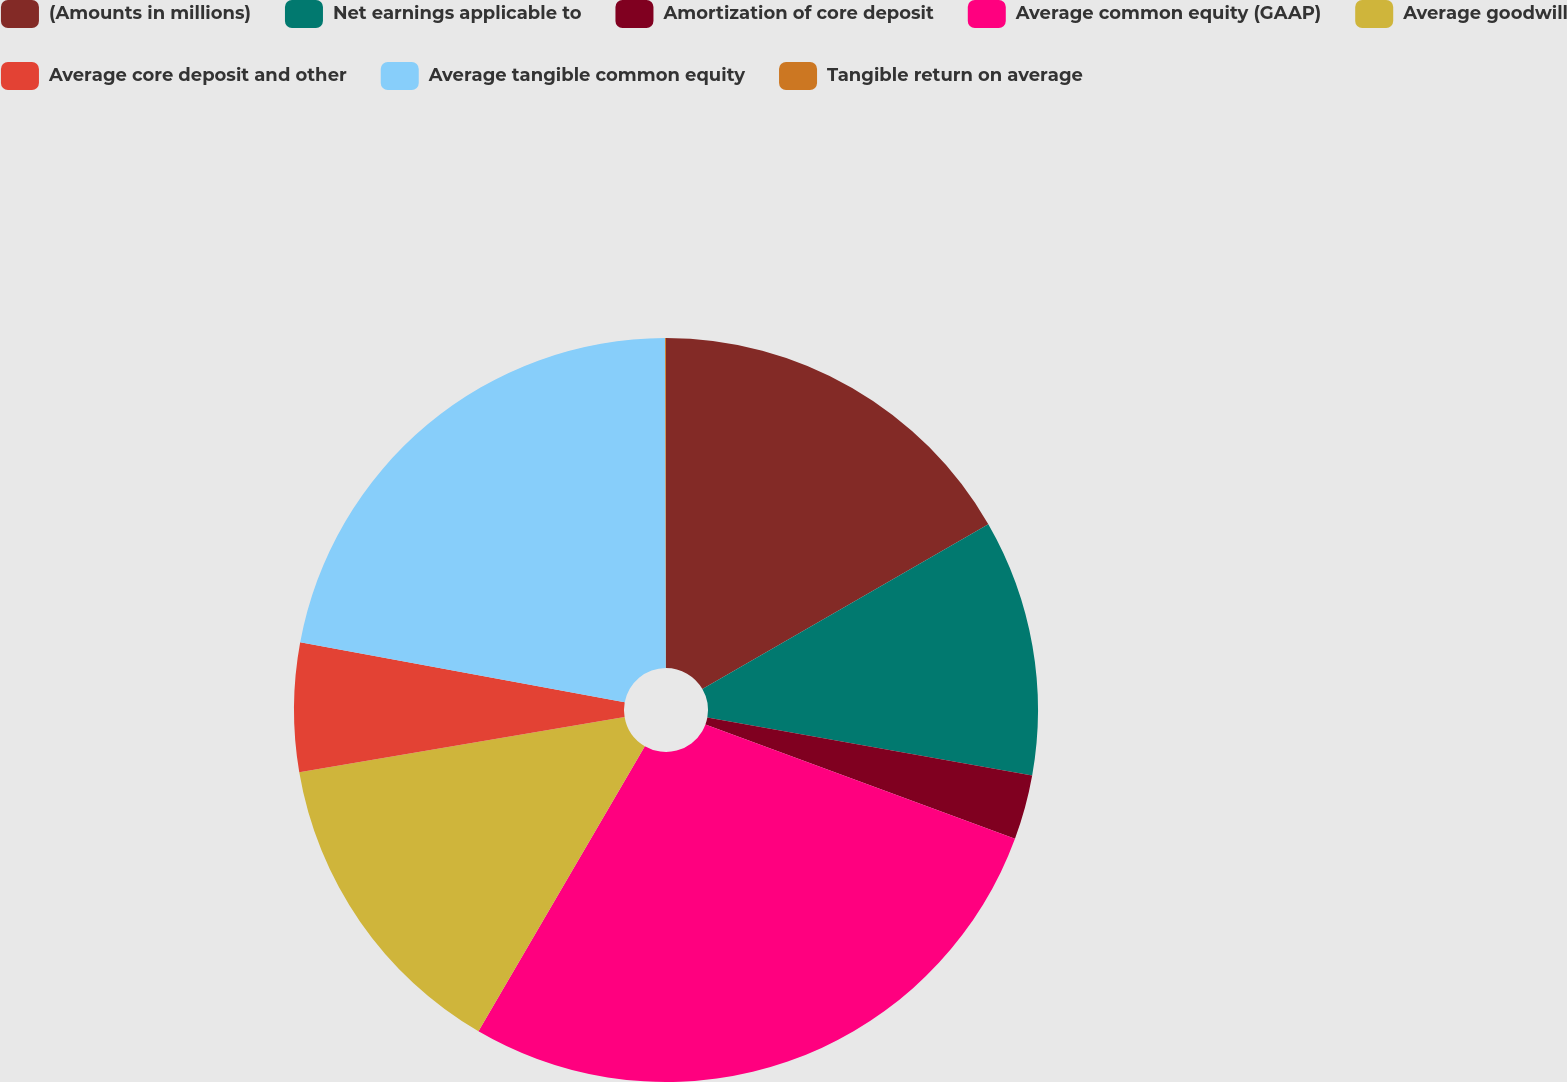Convert chart to OTSL. <chart><loc_0><loc_0><loc_500><loc_500><pie_chart><fcel>(Amounts in millions)<fcel>Net earnings applicable to<fcel>Amortization of core deposit<fcel>Average common equity (GAAP)<fcel>Average goodwill<fcel>Average core deposit and other<fcel>Average tangible common equity<fcel>Tangible return on average<nl><fcel>16.68%<fcel>11.14%<fcel>2.81%<fcel>27.78%<fcel>13.91%<fcel>5.59%<fcel>22.05%<fcel>0.04%<nl></chart> 